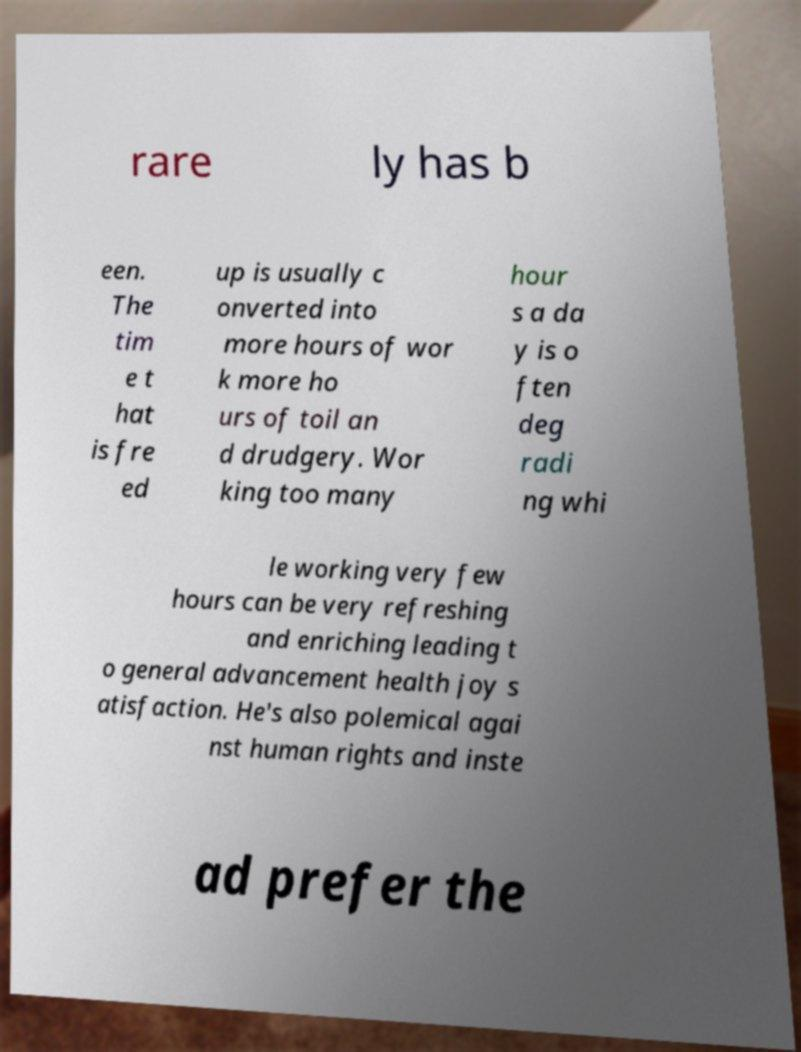For documentation purposes, I need the text within this image transcribed. Could you provide that? rare ly has b een. The tim e t hat is fre ed up is usually c onverted into more hours of wor k more ho urs of toil an d drudgery. Wor king too many hour s a da y is o ften deg radi ng whi le working very few hours can be very refreshing and enriching leading t o general advancement health joy s atisfaction. He's also polemical agai nst human rights and inste ad prefer the 